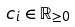Convert formula to latex. <formula><loc_0><loc_0><loc_500><loc_500>c _ { i } \in { \mathbb { R } } _ { \geq 0 }</formula> 